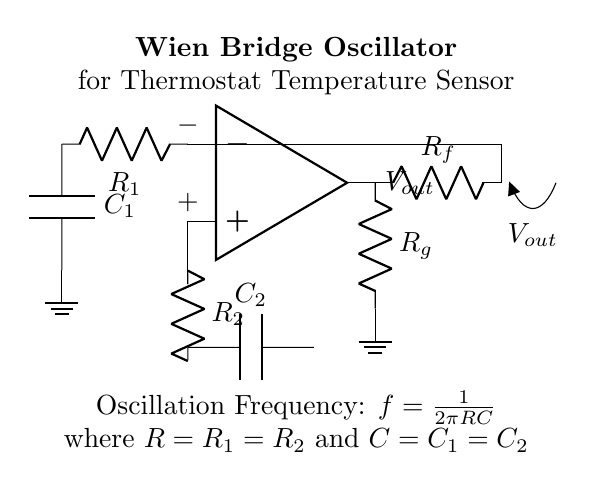What type of oscillator is this circuit? The circuit is a Wien bridge oscillator, which is indicated by the presence of resistors and capacitors configured in a bridge format connected to an operational amplifier.
Answer: Wien bridge oscillator What does the output voltage represent? The output voltage represents the oscillation generated by the Wien bridge oscillator, typically denoted as Vout in the circuit diagram, which is taken from the output terminal of the operational amplifier.
Answer: Vout How many resistors are used in the circuit? There are four resistors in total: R1, R2, Rf, and Rg, based on the circuit components visible.
Answer: Four What is the relationship between R and C in the oscillation frequency equation? In the equation for oscillation frequency \( f = \frac{1}{2\pi RC} \), R represents the resistance that is the same for R1 and R2, and C represents the capacitance that is the same for C1 and C2, indicating a harmonic relationship where frequency is inversely proportional to the product of resistance and capacitance.
Answer: Inversely proportional What is the required condition for oscillation in this circuit? The condition that needs to be met for the Wien bridge oscillator to oscillate is that the gain around the loop must equal one; this is facilitated by the feedback resistors Rf and Rg that adjust as necessary for stable oscillations.
Answer: Gain equals one Which components set the oscillation frequency? The oscillation frequency is set by resistors R1, R2, and capacitors C1, C2 because the frequency equation directly involves these components’ values.
Answer: R1, R2, C1, C2 